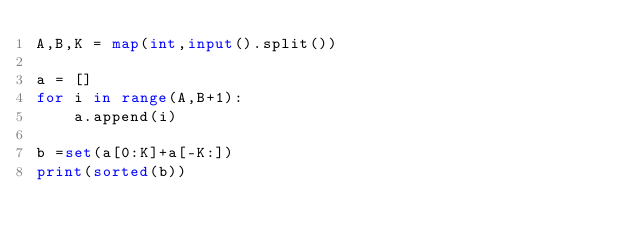Convert code to text. <code><loc_0><loc_0><loc_500><loc_500><_Python_>A,B,K = map(int,input().split())

a = []
for i in range(A,B+1):
    a.append(i)

b =set(a[0:K]+a[-K:])
print(sorted(b))
</code> 